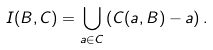<formula> <loc_0><loc_0><loc_500><loc_500>I ( B , C ) = \bigcup _ { a \in C } \left ( C ( a , B ) - a \right ) .</formula> 